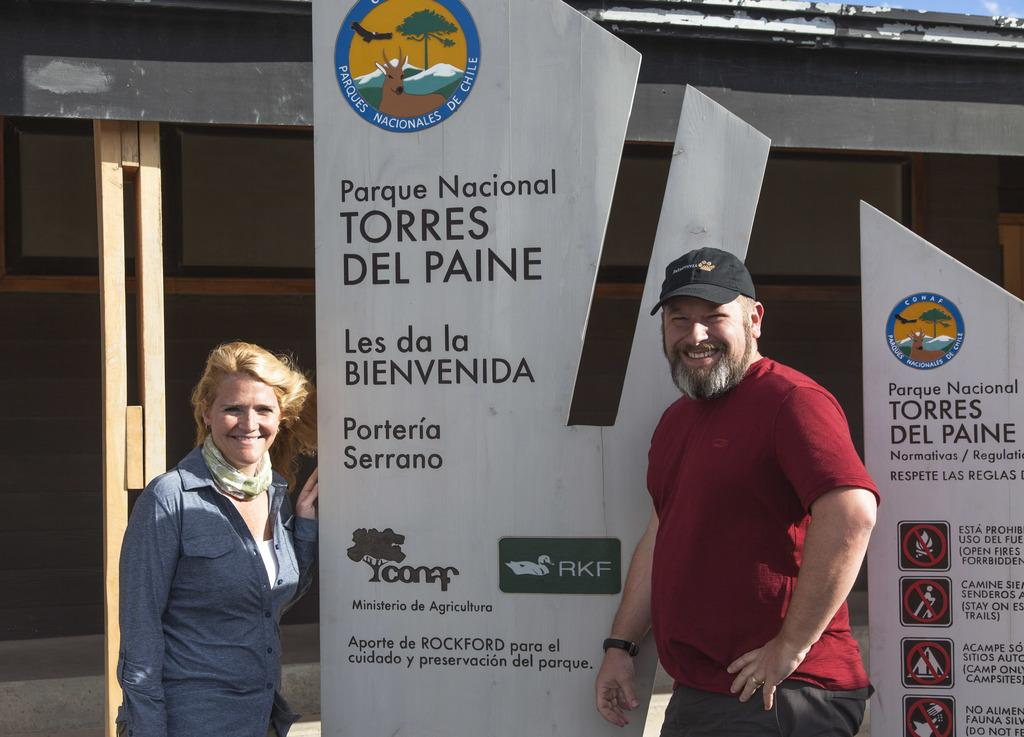How many people are present in the image? There are two people, a man and a woman, present in the image. What can be seen on the wall in the image? There is a poster in the image. What type of structure is visible in the background of the image? There is a shed in the background of the image. Can you see any blood on the man's clothes in the image? There is no blood visible on the man's clothes in the image. What type of seashore can be seen in the background of the image? There is no seashore present in the image; it features a shed in the background. 